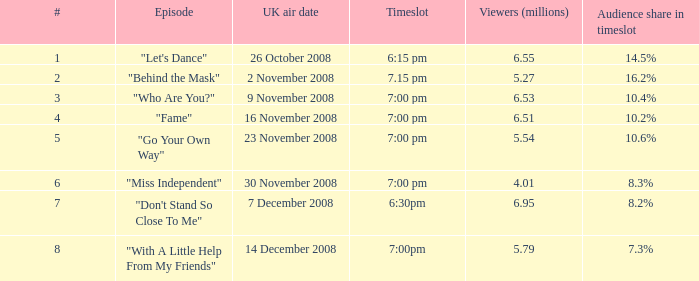9 7.0. Can you parse all the data within this table? {'header': ['#', 'Episode', 'UK air date', 'Timeslot', 'Viewers (millions)', 'Audience share in timeslot'], 'rows': [['1', '"Let\'s Dance"', '26 October 2008', '6:15 pm', '6.55', '14.5%'], ['2', '"Behind the Mask"', '2 November 2008', '7.15 pm', '5.27', '16.2%'], ['3', '"Who Are You?"', '9 November 2008', '7:00 pm', '6.53', '10.4%'], ['4', '"Fame"', '16 November 2008', '7:00 pm', '6.51', '10.2%'], ['5', '"Go Your Own Way"', '23 November 2008', '7:00 pm', '5.54', '10.6%'], ['6', '"Miss Independent"', '30 November 2008', '7:00 pm', '4.01', '8.3%'], ['7', '"Don\'t Stand So Close To Me"', '7 December 2008', '6:30pm', '6.95', '8.2%'], ['8', '"With A Little Help From My Friends"', '14 December 2008', '7:00pm', '5.79', '7.3%']]} 